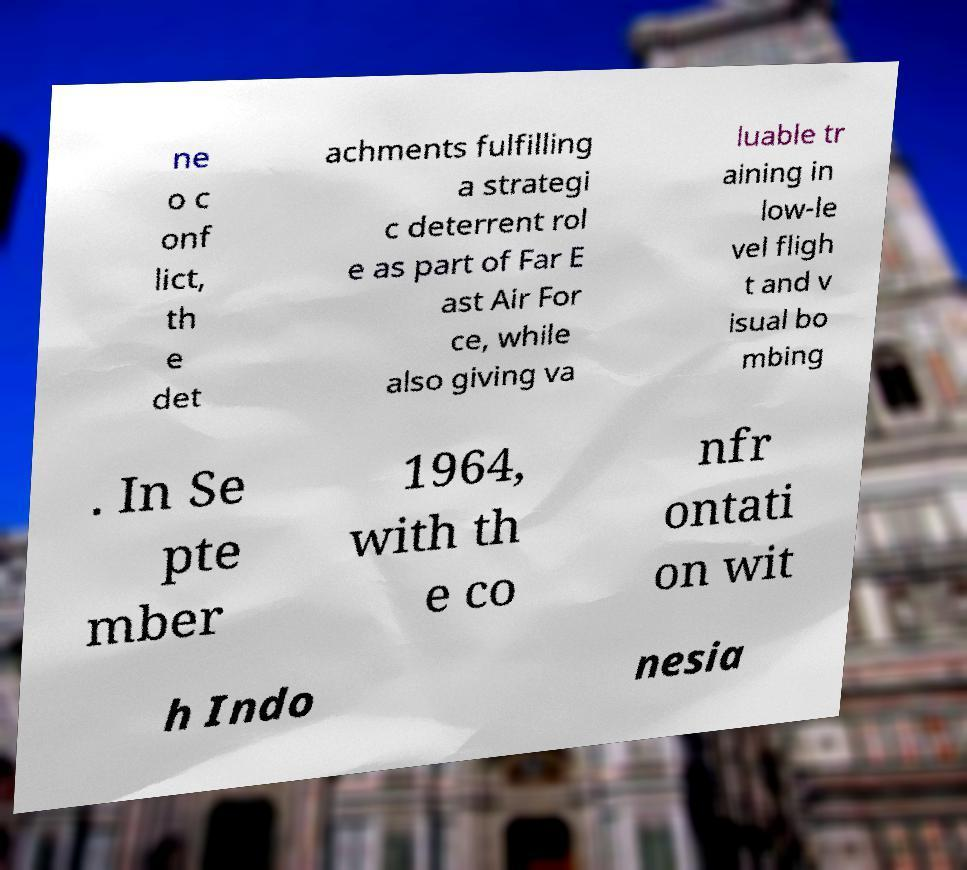I need the written content from this picture converted into text. Can you do that? ne o c onf lict, th e det achments fulfilling a strategi c deterrent rol e as part of Far E ast Air For ce, while also giving va luable tr aining in low-le vel fligh t and v isual bo mbing . In Se pte mber 1964, with th e co nfr ontati on wit h Indo nesia 